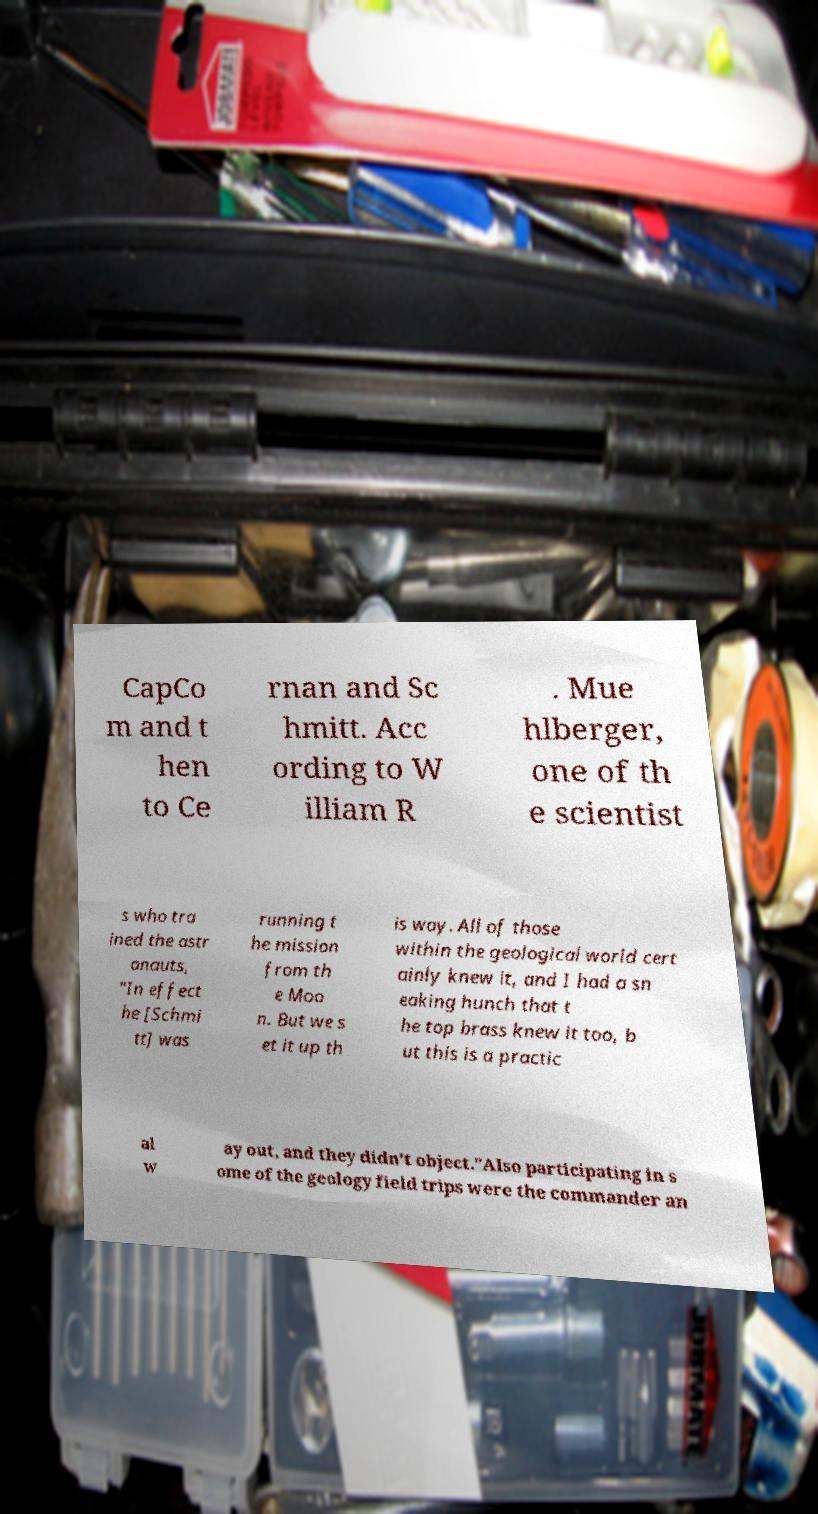I need the written content from this picture converted into text. Can you do that? CapCo m and t hen to Ce rnan and Sc hmitt. Acc ording to W illiam R . Mue hlberger, one of th e scientist s who tra ined the astr onauts, "In effect he [Schmi tt] was running t he mission from th e Moo n. But we s et it up th is way. All of those within the geological world cert ainly knew it, and I had a sn eaking hunch that t he top brass knew it too, b ut this is a practic al w ay out, and they didn’t object."Also participating in s ome of the geology field trips were the commander an 